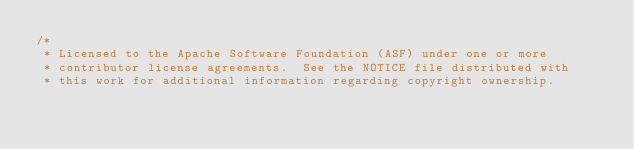Convert code to text. <code><loc_0><loc_0><loc_500><loc_500><_Scala_>/*
 * Licensed to the Apache Software Foundation (ASF) under one or more
 * contributor license agreements.  See the NOTICE file distributed with
 * this work for additional information regarding copyright ownership.</code> 